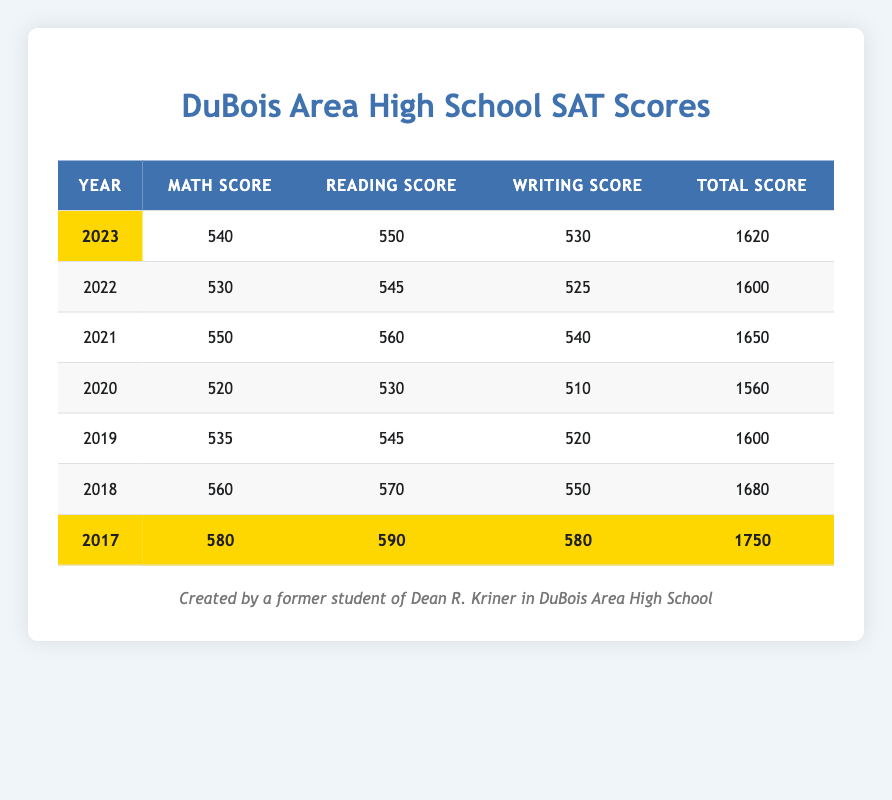What was the highest total SAT score across the years? Looking through the table, the highest total score is found in the year 2017, which is 1750.
Answer: 1750 In which year did DuBois Area High School achieve the highest Math score? The highest Math score is recorded in 2017, which was 580.
Answer: 2017 What are the average Reading scores from 2018 to 2023? Summing up the Reading scores from 2018 to 2023: (570 + 550 + 560 + 545 + 550) = 2875. There are 6 years, so the average is 2875 / 6 = 479.17.
Answer: 479.17 Was the average total SAT score higher in 2021 compared to 2020? The average total SAT score in 2021 is 1650, while in 2020 it is 1560. Since 1650 > 1560, the average score in 2021 is higher.
Answer: Yes What was the difference in Writing scores between the years 2018 and 2017? The Writing score in 2018 is 550 and in 2017 is 580. The difference is 580 - 550 = 30.
Answer: 30 In what year did the students have a total average SAT score of 1600? The years with a total average score of 1600 are 2022 and 2019.
Answer: 2022, 2019 What was the total score in 2020 compared to the total score in 2023? The total score in 2020 is 1560 and in 2023 it is 1620. The total score in 2023 is higher by 1620 - 1560 = 60.
Answer: 60 Which subject had the lowest average score over the years 2017 to 2023? The average scores for each subject from 2017-2023 are calculated. The Writing average is the lowest at 551.67 (540 + 525 + 540 + 510 + 520 + 550 + 580 = 3275, 3275 / 7).
Answer: Writing Did DuBois Area High School's Math scores show an increasing trend from 2019 to 2023? Examining the Math scores: 535 (2019), 520 (2020), 550 (2021), 530 (2022), and 540 (2023) shows that the scores do not show a consistent increase from 2019 to 2023.
Answer: No What is the total of all Writing scores from the years provided? Summing the Writing scores: (530 + 525 + 540 + 510 + 520 + 550 + 580) = 3155.
Answer: 3155 